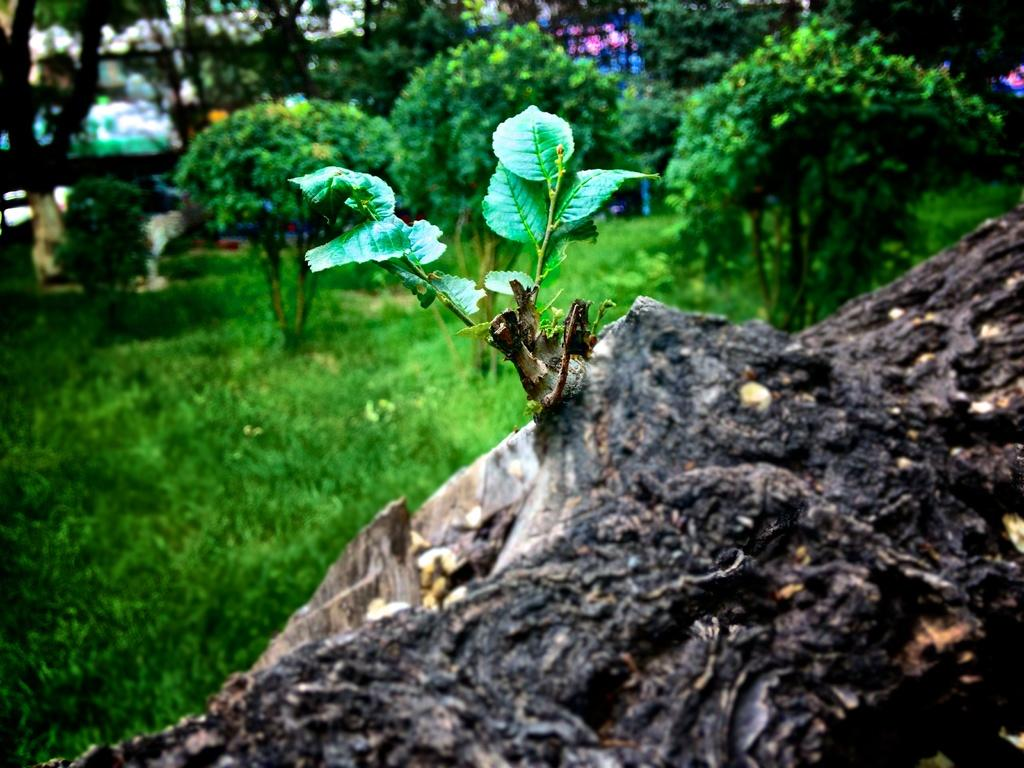What is the main subject in the foreground of the image? There is a tree trunk in the image. What type of vegetation is visible on the ground in the image? There is grass and plants on the ground in the image. What can be seen in the background of the image? There are trees and some unspecified objects in the background of the image. What are the names of the babies playing with paint in the image? There are no babies or paint present in the image. 